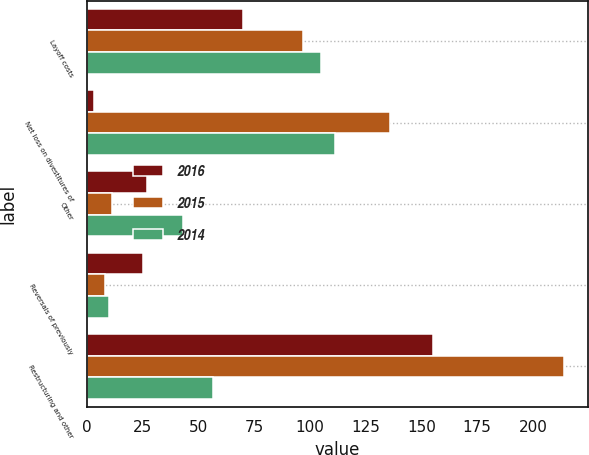<chart> <loc_0><loc_0><loc_500><loc_500><stacked_bar_chart><ecel><fcel>Layoff costs<fcel>Net loss on divestitures of<fcel>Other<fcel>Reversals of previously<fcel>Restructuring and other<nl><fcel>2016<fcel>70<fcel>3<fcel>27<fcel>25<fcel>155<nl><fcel>2015<fcel>97<fcel>136<fcel>11<fcel>8<fcel>214<nl><fcel>2014<fcel>105<fcel>111<fcel>43<fcel>10<fcel>56.5<nl></chart> 